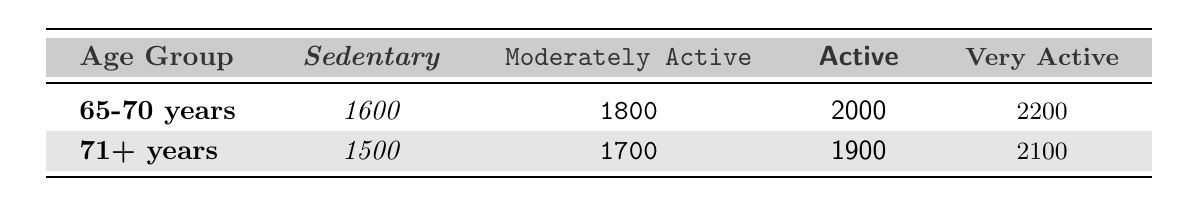What is the recommended caloric intake for a 65-70-year-old who is sedentary? Referring to the table, the caloric intake for the age group 65-70 years in the sedentary category is listed as 1600.
Answer: 1600 What is the caloric intake for someone who is very active and over 71 years old? By checking the table, for the age group 71+ years under the very active classification, the recommended intake is 2100.
Answer: 2100 Is the caloric intake for a moderately active person age 65-70 higher than that for a sedentary person age 71+? Comparing the values, the caloric intake for a moderately active person aged 65-70 is 1800, and for a sedentary person aged 71+ it is 1500. Since 1800 > 1500, the statement is true.
Answer: Yes What is the difference in caloric intake between an active person aged 65-70 and a very active person aged 71+? Looking at the table, the caloric intake for an active 65-70 year old is 2000 and for a very active 71+ year old is 2100. The difference is 2100 - 2000 = 100.
Answer: 100 What is the average caloric intake for a sedentary person aged 65-70 and a sedentary person aged 71+? The sedentary caloric intakes are 1600 for 65-70 years and 1500 for 71+. To find the average, we calculate (1600 + 1500) / 2 = 1550.
Answer: 1550 Which age group requires the highest caloric intake if they are classified as very active? Referring to the table, the caloric intake for the age group 65-70 years under very active is 2200, and for 71+ years, it is 2100. The highest intake occurs in the 65-70 years group.
Answer: 65-70 years Is the caloric intake for a moderately active 71+ year old the same as an active 65-70 year old? According to the table, the caloric intake for a moderately active 71+ year old is 1700, while that for an active 65-70 year old is 2000. Since 1700 is not equal to 2000, the answer is no.
Answer: No If someone aged 71+ is active, how does their caloric intake compare to that of a moderately active person aged 65-70? The caloric intake for an active 71+ is 1900, and for a moderately active 65-70 is 1800. Since 1900 is greater than 1800, the active 71+ year old consumes more.
Answer: Active 71+ consumes more What is the combined caloric intake for all activity levels for someone aged 65-70? The total caloric intake across all activity levels for 65-70 years is 1600 (sedentary) + 1800 (moderately active) + 2000 (active) + 2200 (very active) = 7600.
Answer: 7600 Which age group has the lowest caloric intake for a sedentary lifestyle? By examining the table, we find that the sedentary caloric intake for 65-70 years is 1600, and for 71+ years, it is 1500. Therefore, the age group 71+ has the lowest intake.
Answer: 71+ years 